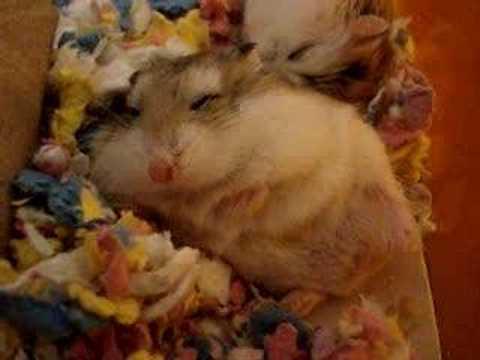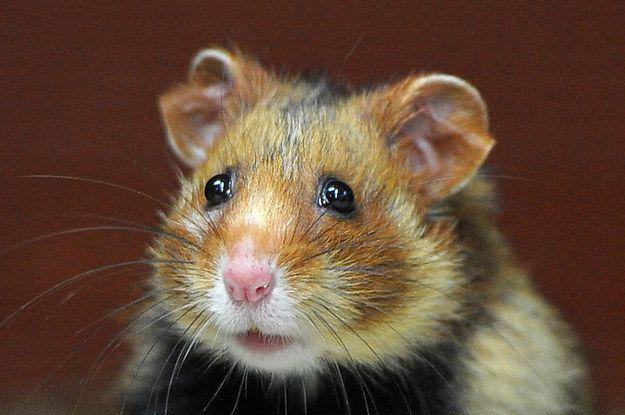The first image is the image on the left, the second image is the image on the right. For the images displayed, is the sentence "An image shows pet rodents inside a container with an opening at the front." factually correct? Answer yes or no. No. The first image is the image on the left, the second image is the image on the right. Analyze the images presented: Is the assertion "There is human hand carrying a hamster." valid? Answer yes or no. No. 